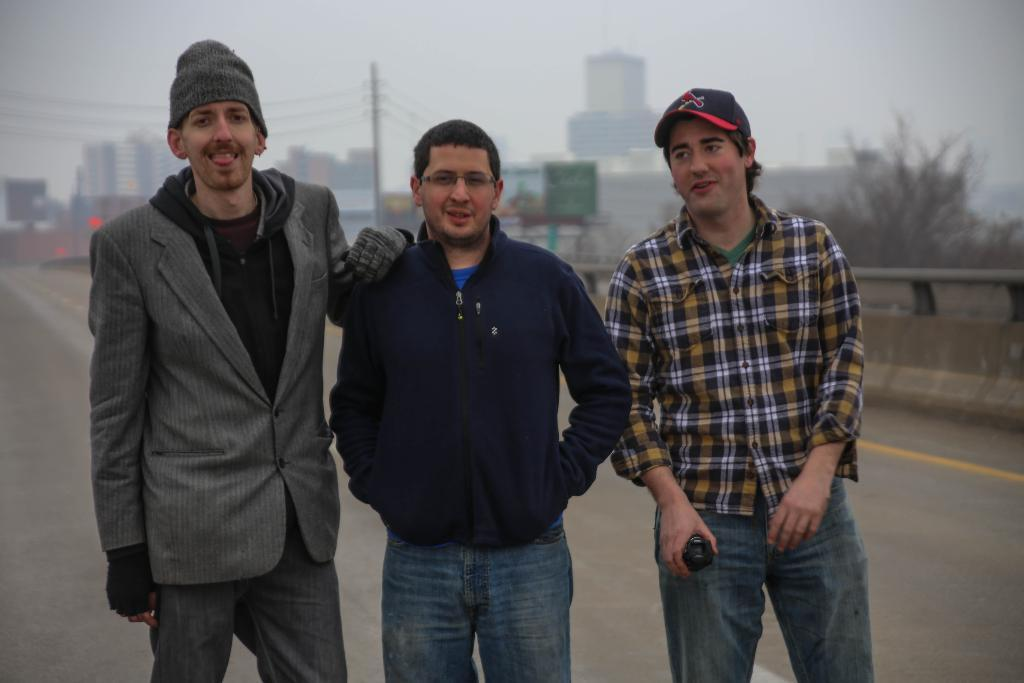How many people are standing on the road in the image? There are three persons standing on the road in the image. What can be seen in the background of the image? Buildings, electric poles, trees, and the sky are visible in the background of the image. What type of nose can be seen on the electric poles in the image? There are no noses present on the electric poles in the image, as they are inanimate objects. 